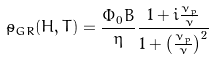<formula> <loc_0><loc_0><loc_500><loc_500>\tilde { \rho } _ { G R } ( H , T ) = \frac { \Phi _ { 0 } B } { \eta } \frac { 1 + i \frac { \nu _ { p } } { \nu } } { 1 + \left ( \frac { \nu _ { p } } { \nu } \right ) ^ { 2 } }</formula> 